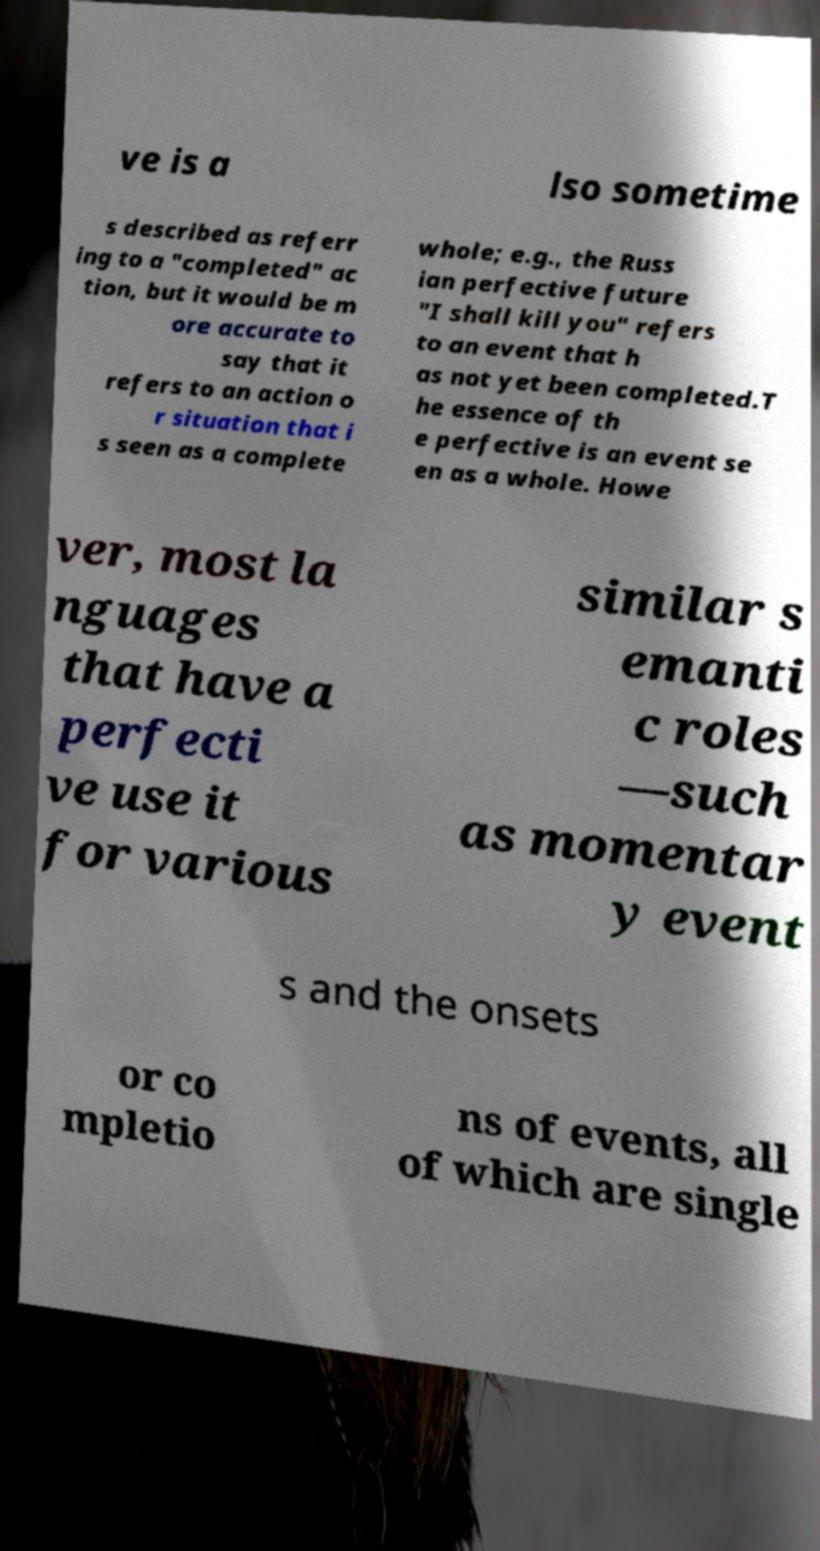Please identify and transcribe the text found in this image. ve is a lso sometime s described as referr ing to a "completed" ac tion, but it would be m ore accurate to say that it refers to an action o r situation that i s seen as a complete whole; e.g., the Russ ian perfective future "I shall kill you" refers to an event that h as not yet been completed.T he essence of th e perfective is an event se en as a whole. Howe ver, most la nguages that have a perfecti ve use it for various similar s emanti c roles —such as momentar y event s and the onsets or co mpletio ns of events, all of which are single 